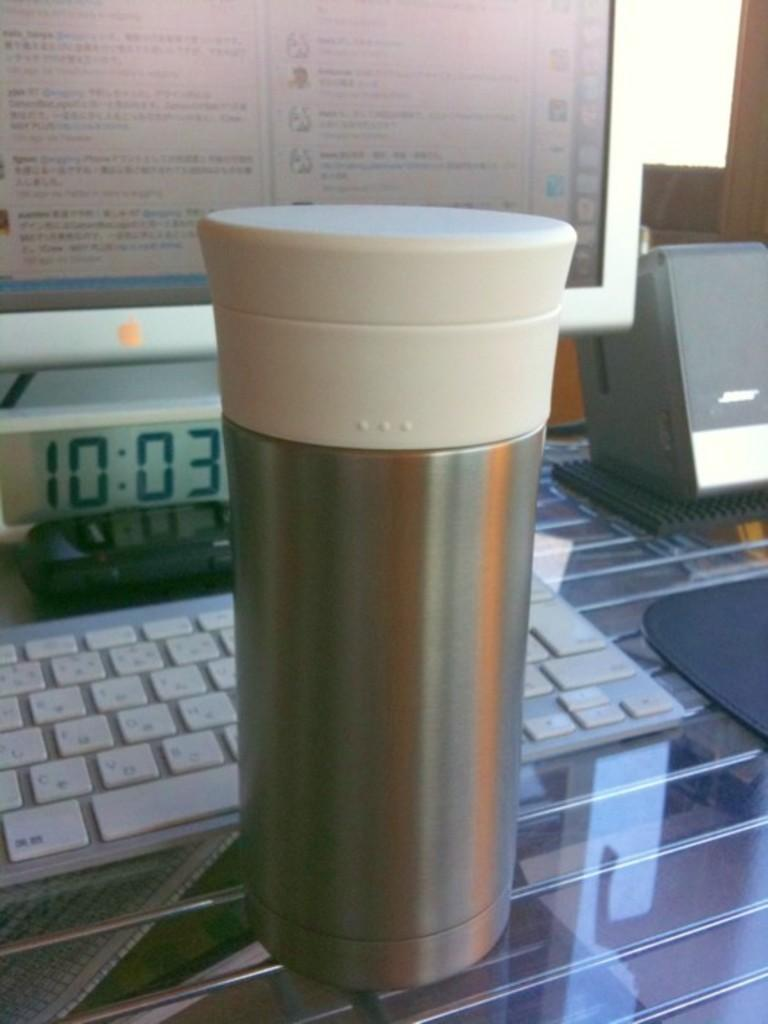Provide a one-sentence caption for the provided image. A thermal sits on a table in front of a keyboard and monitor at 10:03. 